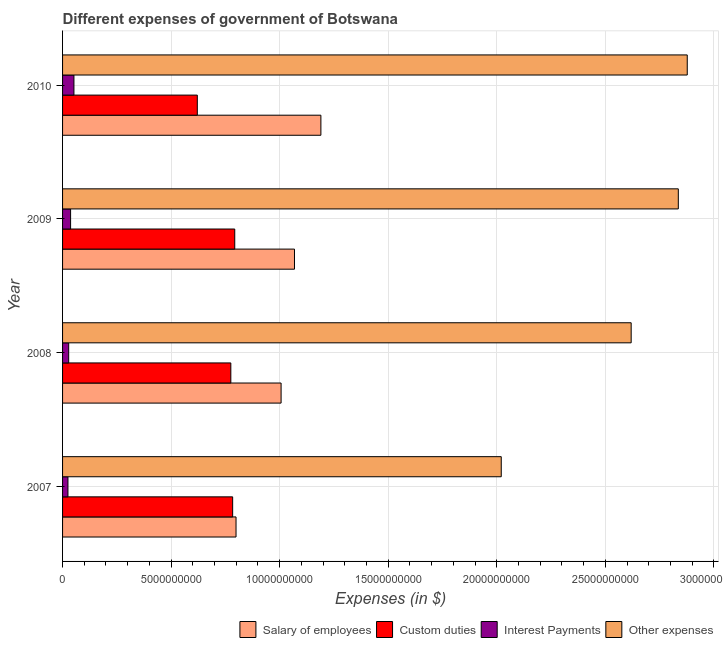Are the number of bars on each tick of the Y-axis equal?
Your answer should be compact. Yes. How many bars are there on the 3rd tick from the top?
Offer a very short reply. 4. What is the amount spent on interest payments in 2010?
Make the answer very short. 5.24e+08. Across all years, what is the maximum amount spent on salary of employees?
Keep it short and to the point. 1.19e+1. Across all years, what is the minimum amount spent on other expenses?
Give a very brief answer. 2.02e+1. In which year was the amount spent on salary of employees maximum?
Offer a terse response. 2010. What is the total amount spent on other expenses in the graph?
Make the answer very short. 1.04e+11. What is the difference between the amount spent on other expenses in 2008 and that in 2010?
Ensure brevity in your answer.  -2.58e+09. What is the difference between the amount spent on interest payments in 2009 and the amount spent on custom duties in 2007?
Offer a terse response. -7.46e+09. What is the average amount spent on interest payments per year?
Your answer should be very brief. 3.56e+08. In the year 2010, what is the difference between the amount spent on salary of employees and amount spent on custom duties?
Ensure brevity in your answer.  5.69e+09. In how many years, is the amount spent on salary of employees greater than 3000000000 $?
Ensure brevity in your answer.  4. What is the ratio of the amount spent on salary of employees in 2009 to that in 2010?
Ensure brevity in your answer.  0.9. What is the difference between the highest and the second highest amount spent on custom duties?
Make the answer very short. 9.62e+07. What is the difference between the highest and the lowest amount spent on custom duties?
Offer a terse response. 1.72e+09. In how many years, is the amount spent on salary of employees greater than the average amount spent on salary of employees taken over all years?
Provide a short and direct response. 2. Is the sum of the amount spent on salary of employees in 2008 and 2010 greater than the maximum amount spent on custom duties across all years?
Offer a terse response. Yes. Is it the case that in every year, the sum of the amount spent on interest payments and amount spent on custom duties is greater than the sum of amount spent on salary of employees and amount spent on other expenses?
Offer a terse response. Yes. What does the 3rd bar from the top in 2009 represents?
Offer a terse response. Custom duties. What does the 2nd bar from the bottom in 2009 represents?
Your answer should be compact. Custom duties. How many bars are there?
Give a very brief answer. 16. How many years are there in the graph?
Your answer should be compact. 4. Are the values on the major ticks of X-axis written in scientific E-notation?
Your response must be concise. No. Where does the legend appear in the graph?
Your response must be concise. Bottom right. How are the legend labels stacked?
Your response must be concise. Horizontal. What is the title of the graph?
Make the answer very short. Different expenses of government of Botswana. What is the label or title of the X-axis?
Your answer should be compact. Expenses (in $). What is the Expenses (in $) in Salary of employees in 2007?
Your answer should be compact. 7.99e+09. What is the Expenses (in $) in Custom duties in 2007?
Give a very brief answer. 7.83e+09. What is the Expenses (in $) of Interest Payments in 2007?
Provide a succinct answer. 2.48e+08. What is the Expenses (in $) in Other expenses in 2007?
Give a very brief answer. 2.02e+1. What is the Expenses (in $) in Salary of employees in 2008?
Your response must be concise. 1.01e+1. What is the Expenses (in $) in Custom duties in 2008?
Offer a very short reply. 7.75e+09. What is the Expenses (in $) in Interest Payments in 2008?
Your response must be concise. 2.82e+08. What is the Expenses (in $) in Other expenses in 2008?
Keep it short and to the point. 2.62e+1. What is the Expenses (in $) of Salary of employees in 2009?
Offer a very short reply. 1.07e+1. What is the Expenses (in $) in Custom duties in 2009?
Your answer should be very brief. 7.93e+09. What is the Expenses (in $) in Interest Payments in 2009?
Ensure brevity in your answer.  3.70e+08. What is the Expenses (in $) in Other expenses in 2009?
Make the answer very short. 2.84e+1. What is the Expenses (in $) of Salary of employees in 2010?
Offer a very short reply. 1.19e+1. What is the Expenses (in $) of Custom duties in 2010?
Make the answer very short. 6.21e+09. What is the Expenses (in $) in Interest Payments in 2010?
Provide a succinct answer. 5.24e+08. What is the Expenses (in $) of Other expenses in 2010?
Give a very brief answer. 2.88e+1. Across all years, what is the maximum Expenses (in $) of Salary of employees?
Provide a short and direct response. 1.19e+1. Across all years, what is the maximum Expenses (in $) of Custom duties?
Your answer should be very brief. 7.93e+09. Across all years, what is the maximum Expenses (in $) in Interest Payments?
Your answer should be compact. 5.24e+08. Across all years, what is the maximum Expenses (in $) of Other expenses?
Provide a short and direct response. 2.88e+1. Across all years, what is the minimum Expenses (in $) of Salary of employees?
Make the answer very short. 7.99e+09. Across all years, what is the minimum Expenses (in $) of Custom duties?
Your response must be concise. 6.21e+09. Across all years, what is the minimum Expenses (in $) in Interest Payments?
Make the answer very short. 2.48e+08. Across all years, what is the minimum Expenses (in $) in Other expenses?
Provide a short and direct response. 2.02e+1. What is the total Expenses (in $) of Salary of employees in the graph?
Offer a very short reply. 4.06e+1. What is the total Expenses (in $) in Custom duties in the graph?
Make the answer very short. 2.97e+1. What is the total Expenses (in $) of Interest Payments in the graph?
Offer a terse response. 1.42e+09. What is the total Expenses (in $) of Other expenses in the graph?
Your answer should be very brief. 1.04e+11. What is the difference between the Expenses (in $) in Salary of employees in 2007 and that in 2008?
Your answer should be very brief. -2.08e+09. What is the difference between the Expenses (in $) in Custom duties in 2007 and that in 2008?
Offer a very short reply. 8.47e+07. What is the difference between the Expenses (in $) in Interest Payments in 2007 and that in 2008?
Offer a very short reply. -3.36e+07. What is the difference between the Expenses (in $) in Other expenses in 2007 and that in 2008?
Provide a short and direct response. -5.98e+09. What is the difference between the Expenses (in $) in Salary of employees in 2007 and that in 2009?
Give a very brief answer. -2.69e+09. What is the difference between the Expenses (in $) in Custom duties in 2007 and that in 2009?
Provide a short and direct response. -9.62e+07. What is the difference between the Expenses (in $) of Interest Payments in 2007 and that in 2009?
Give a very brief answer. -1.21e+08. What is the difference between the Expenses (in $) of Other expenses in 2007 and that in 2009?
Your answer should be very brief. -8.16e+09. What is the difference between the Expenses (in $) in Salary of employees in 2007 and that in 2010?
Ensure brevity in your answer.  -3.91e+09. What is the difference between the Expenses (in $) of Custom duties in 2007 and that in 2010?
Give a very brief answer. 1.63e+09. What is the difference between the Expenses (in $) in Interest Payments in 2007 and that in 2010?
Keep it short and to the point. -2.75e+08. What is the difference between the Expenses (in $) in Other expenses in 2007 and that in 2010?
Offer a very short reply. -8.57e+09. What is the difference between the Expenses (in $) in Salary of employees in 2008 and that in 2009?
Provide a short and direct response. -6.17e+08. What is the difference between the Expenses (in $) in Custom duties in 2008 and that in 2009?
Offer a terse response. -1.81e+08. What is the difference between the Expenses (in $) in Interest Payments in 2008 and that in 2009?
Provide a short and direct response. -8.77e+07. What is the difference between the Expenses (in $) in Other expenses in 2008 and that in 2009?
Your answer should be compact. -2.17e+09. What is the difference between the Expenses (in $) in Salary of employees in 2008 and that in 2010?
Offer a very short reply. -1.83e+09. What is the difference between the Expenses (in $) in Custom duties in 2008 and that in 2010?
Make the answer very short. 1.54e+09. What is the difference between the Expenses (in $) of Interest Payments in 2008 and that in 2010?
Your answer should be very brief. -2.41e+08. What is the difference between the Expenses (in $) of Other expenses in 2008 and that in 2010?
Your response must be concise. -2.58e+09. What is the difference between the Expenses (in $) in Salary of employees in 2009 and that in 2010?
Your answer should be very brief. -1.22e+09. What is the difference between the Expenses (in $) of Custom duties in 2009 and that in 2010?
Make the answer very short. 1.72e+09. What is the difference between the Expenses (in $) in Interest Payments in 2009 and that in 2010?
Offer a terse response. -1.54e+08. What is the difference between the Expenses (in $) in Other expenses in 2009 and that in 2010?
Offer a terse response. -4.12e+08. What is the difference between the Expenses (in $) of Salary of employees in 2007 and the Expenses (in $) of Custom duties in 2008?
Ensure brevity in your answer.  2.40e+08. What is the difference between the Expenses (in $) of Salary of employees in 2007 and the Expenses (in $) of Interest Payments in 2008?
Your response must be concise. 7.71e+09. What is the difference between the Expenses (in $) of Salary of employees in 2007 and the Expenses (in $) of Other expenses in 2008?
Your answer should be compact. -1.82e+1. What is the difference between the Expenses (in $) of Custom duties in 2007 and the Expenses (in $) of Interest Payments in 2008?
Offer a very short reply. 7.55e+09. What is the difference between the Expenses (in $) of Custom duties in 2007 and the Expenses (in $) of Other expenses in 2008?
Make the answer very short. -1.84e+1. What is the difference between the Expenses (in $) of Interest Payments in 2007 and the Expenses (in $) of Other expenses in 2008?
Your response must be concise. -2.59e+1. What is the difference between the Expenses (in $) of Salary of employees in 2007 and the Expenses (in $) of Custom duties in 2009?
Keep it short and to the point. 5.93e+07. What is the difference between the Expenses (in $) in Salary of employees in 2007 and the Expenses (in $) in Interest Payments in 2009?
Keep it short and to the point. 7.62e+09. What is the difference between the Expenses (in $) of Salary of employees in 2007 and the Expenses (in $) of Other expenses in 2009?
Make the answer very short. -2.04e+1. What is the difference between the Expenses (in $) in Custom duties in 2007 and the Expenses (in $) in Interest Payments in 2009?
Keep it short and to the point. 7.46e+09. What is the difference between the Expenses (in $) of Custom duties in 2007 and the Expenses (in $) of Other expenses in 2009?
Provide a succinct answer. -2.05e+1. What is the difference between the Expenses (in $) of Interest Payments in 2007 and the Expenses (in $) of Other expenses in 2009?
Offer a very short reply. -2.81e+1. What is the difference between the Expenses (in $) of Salary of employees in 2007 and the Expenses (in $) of Custom duties in 2010?
Your answer should be very brief. 1.78e+09. What is the difference between the Expenses (in $) of Salary of employees in 2007 and the Expenses (in $) of Interest Payments in 2010?
Make the answer very short. 7.47e+09. What is the difference between the Expenses (in $) of Salary of employees in 2007 and the Expenses (in $) of Other expenses in 2010?
Your response must be concise. -2.08e+1. What is the difference between the Expenses (in $) in Custom duties in 2007 and the Expenses (in $) in Interest Payments in 2010?
Your answer should be very brief. 7.31e+09. What is the difference between the Expenses (in $) of Custom duties in 2007 and the Expenses (in $) of Other expenses in 2010?
Offer a very short reply. -2.09e+1. What is the difference between the Expenses (in $) of Interest Payments in 2007 and the Expenses (in $) of Other expenses in 2010?
Your answer should be very brief. -2.85e+1. What is the difference between the Expenses (in $) of Salary of employees in 2008 and the Expenses (in $) of Custom duties in 2009?
Ensure brevity in your answer.  2.13e+09. What is the difference between the Expenses (in $) in Salary of employees in 2008 and the Expenses (in $) in Interest Payments in 2009?
Offer a terse response. 9.70e+09. What is the difference between the Expenses (in $) in Salary of employees in 2008 and the Expenses (in $) in Other expenses in 2009?
Provide a short and direct response. -1.83e+1. What is the difference between the Expenses (in $) of Custom duties in 2008 and the Expenses (in $) of Interest Payments in 2009?
Make the answer very short. 7.38e+09. What is the difference between the Expenses (in $) in Custom duties in 2008 and the Expenses (in $) in Other expenses in 2009?
Make the answer very short. -2.06e+1. What is the difference between the Expenses (in $) in Interest Payments in 2008 and the Expenses (in $) in Other expenses in 2009?
Offer a very short reply. -2.81e+1. What is the difference between the Expenses (in $) in Salary of employees in 2008 and the Expenses (in $) in Custom duties in 2010?
Provide a succinct answer. 3.86e+09. What is the difference between the Expenses (in $) in Salary of employees in 2008 and the Expenses (in $) in Interest Payments in 2010?
Your answer should be compact. 9.54e+09. What is the difference between the Expenses (in $) of Salary of employees in 2008 and the Expenses (in $) of Other expenses in 2010?
Give a very brief answer. -1.87e+1. What is the difference between the Expenses (in $) in Custom duties in 2008 and the Expenses (in $) in Interest Payments in 2010?
Provide a short and direct response. 7.23e+09. What is the difference between the Expenses (in $) in Custom duties in 2008 and the Expenses (in $) in Other expenses in 2010?
Ensure brevity in your answer.  -2.10e+1. What is the difference between the Expenses (in $) of Interest Payments in 2008 and the Expenses (in $) of Other expenses in 2010?
Give a very brief answer. -2.85e+1. What is the difference between the Expenses (in $) in Salary of employees in 2009 and the Expenses (in $) in Custom duties in 2010?
Keep it short and to the point. 4.48e+09. What is the difference between the Expenses (in $) in Salary of employees in 2009 and the Expenses (in $) in Interest Payments in 2010?
Your answer should be compact. 1.02e+1. What is the difference between the Expenses (in $) in Salary of employees in 2009 and the Expenses (in $) in Other expenses in 2010?
Offer a terse response. -1.81e+1. What is the difference between the Expenses (in $) in Custom duties in 2009 and the Expenses (in $) in Interest Payments in 2010?
Your answer should be very brief. 7.41e+09. What is the difference between the Expenses (in $) of Custom duties in 2009 and the Expenses (in $) of Other expenses in 2010?
Your response must be concise. -2.08e+1. What is the difference between the Expenses (in $) in Interest Payments in 2009 and the Expenses (in $) in Other expenses in 2010?
Offer a very short reply. -2.84e+1. What is the average Expenses (in $) of Salary of employees per year?
Your response must be concise. 1.02e+1. What is the average Expenses (in $) in Custom duties per year?
Offer a terse response. 7.43e+09. What is the average Expenses (in $) of Interest Payments per year?
Provide a short and direct response. 3.56e+08. What is the average Expenses (in $) in Other expenses per year?
Your response must be concise. 2.59e+1. In the year 2007, what is the difference between the Expenses (in $) of Salary of employees and Expenses (in $) of Custom duties?
Your answer should be very brief. 1.55e+08. In the year 2007, what is the difference between the Expenses (in $) of Salary of employees and Expenses (in $) of Interest Payments?
Provide a succinct answer. 7.74e+09. In the year 2007, what is the difference between the Expenses (in $) in Salary of employees and Expenses (in $) in Other expenses?
Your answer should be very brief. -1.22e+1. In the year 2007, what is the difference between the Expenses (in $) of Custom duties and Expenses (in $) of Interest Payments?
Give a very brief answer. 7.59e+09. In the year 2007, what is the difference between the Expenses (in $) of Custom duties and Expenses (in $) of Other expenses?
Your response must be concise. -1.24e+1. In the year 2007, what is the difference between the Expenses (in $) in Interest Payments and Expenses (in $) in Other expenses?
Make the answer very short. -2.00e+1. In the year 2008, what is the difference between the Expenses (in $) of Salary of employees and Expenses (in $) of Custom duties?
Provide a succinct answer. 2.32e+09. In the year 2008, what is the difference between the Expenses (in $) in Salary of employees and Expenses (in $) in Interest Payments?
Provide a short and direct response. 9.78e+09. In the year 2008, what is the difference between the Expenses (in $) of Salary of employees and Expenses (in $) of Other expenses?
Provide a short and direct response. -1.61e+1. In the year 2008, what is the difference between the Expenses (in $) in Custom duties and Expenses (in $) in Interest Payments?
Offer a very short reply. 7.47e+09. In the year 2008, what is the difference between the Expenses (in $) of Custom duties and Expenses (in $) of Other expenses?
Provide a succinct answer. -1.84e+1. In the year 2008, what is the difference between the Expenses (in $) of Interest Payments and Expenses (in $) of Other expenses?
Your response must be concise. -2.59e+1. In the year 2009, what is the difference between the Expenses (in $) in Salary of employees and Expenses (in $) in Custom duties?
Your answer should be compact. 2.75e+09. In the year 2009, what is the difference between the Expenses (in $) in Salary of employees and Expenses (in $) in Interest Payments?
Provide a short and direct response. 1.03e+1. In the year 2009, what is the difference between the Expenses (in $) in Salary of employees and Expenses (in $) in Other expenses?
Provide a short and direct response. -1.77e+1. In the year 2009, what is the difference between the Expenses (in $) in Custom duties and Expenses (in $) in Interest Payments?
Provide a short and direct response. 7.56e+09. In the year 2009, what is the difference between the Expenses (in $) of Custom duties and Expenses (in $) of Other expenses?
Ensure brevity in your answer.  -2.04e+1. In the year 2009, what is the difference between the Expenses (in $) in Interest Payments and Expenses (in $) in Other expenses?
Your answer should be compact. -2.80e+1. In the year 2010, what is the difference between the Expenses (in $) in Salary of employees and Expenses (in $) in Custom duties?
Your answer should be very brief. 5.69e+09. In the year 2010, what is the difference between the Expenses (in $) of Salary of employees and Expenses (in $) of Interest Payments?
Provide a short and direct response. 1.14e+1. In the year 2010, what is the difference between the Expenses (in $) of Salary of employees and Expenses (in $) of Other expenses?
Keep it short and to the point. -1.69e+1. In the year 2010, what is the difference between the Expenses (in $) in Custom duties and Expenses (in $) in Interest Payments?
Keep it short and to the point. 5.68e+09. In the year 2010, what is the difference between the Expenses (in $) in Custom duties and Expenses (in $) in Other expenses?
Provide a succinct answer. -2.26e+1. In the year 2010, what is the difference between the Expenses (in $) in Interest Payments and Expenses (in $) in Other expenses?
Give a very brief answer. -2.83e+1. What is the ratio of the Expenses (in $) in Salary of employees in 2007 to that in 2008?
Provide a succinct answer. 0.79. What is the ratio of the Expenses (in $) of Custom duties in 2007 to that in 2008?
Make the answer very short. 1.01. What is the ratio of the Expenses (in $) in Interest Payments in 2007 to that in 2008?
Give a very brief answer. 0.88. What is the ratio of the Expenses (in $) in Other expenses in 2007 to that in 2008?
Your answer should be compact. 0.77. What is the ratio of the Expenses (in $) of Salary of employees in 2007 to that in 2009?
Offer a very short reply. 0.75. What is the ratio of the Expenses (in $) in Custom duties in 2007 to that in 2009?
Your answer should be very brief. 0.99. What is the ratio of the Expenses (in $) of Interest Payments in 2007 to that in 2009?
Your response must be concise. 0.67. What is the ratio of the Expenses (in $) in Other expenses in 2007 to that in 2009?
Ensure brevity in your answer.  0.71. What is the ratio of the Expenses (in $) of Salary of employees in 2007 to that in 2010?
Provide a short and direct response. 0.67. What is the ratio of the Expenses (in $) in Custom duties in 2007 to that in 2010?
Provide a short and direct response. 1.26. What is the ratio of the Expenses (in $) of Interest Payments in 2007 to that in 2010?
Your answer should be compact. 0.47. What is the ratio of the Expenses (in $) of Other expenses in 2007 to that in 2010?
Give a very brief answer. 0.7. What is the ratio of the Expenses (in $) of Salary of employees in 2008 to that in 2009?
Provide a succinct answer. 0.94. What is the ratio of the Expenses (in $) in Custom duties in 2008 to that in 2009?
Your answer should be very brief. 0.98. What is the ratio of the Expenses (in $) in Interest Payments in 2008 to that in 2009?
Your response must be concise. 0.76. What is the ratio of the Expenses (in $) of Other expenses in 2008 to that in 2009?
Offer a terse response. 0.92. What is the ratio of the Expenses (in $) of Salary of employees in 2008 to that in 2010?
Your answer should be compact. 0.85. What is the ratio of the Expenses (in $) of Custom duties in 2008 to that in 2010?
Make the answer very short. 1.25. What is the ratio of the Expenses (in $) in Interest Payments in 2008 to that in 2010?
Give a very brief answer. 0.54. What is the ratio of the Expenses (in $) of Other expenses in 2008 to that in 2010?
Offer a terse response. 0.91. What is the ratio of the Expenses (in $) of Salary of employees in 2009 to that in 2010?
Offer a terse response. 0.9. What is the ratio of the Expenses (in $) of Custom duties in 2009 to that in 2010?
Provide a succinct answer. 1.28. What is the ratio of the Expenses (in $) of Interest Payments in 2009 to that in 2010?
Keep it short and to the point. 0.71. What is the ratio of the Expenses (in $) in Other expenses in 2009 to that in 2010?
Offer a very short reply. 0.99. What is the difference between the highest and the second highest Expenses (in $) in Salary of employees?
Provide a short and direct response. 1.22e+09. What is the difference between the highest and the second highest Expenses (in $) in Custom duties?
Make the answer very short. 9.62e+07. What is the difference between the highest and the second highest Expenses (in $) of Interest Payments?
Offer a terse response. 1.54e+08. What is the difference between the highest and the second highest Expenses (in $) in Other expenses?
Offer a very short reply. 4.12e+08. What is the difference between the highest and the lowest Expenses (in $) of Salary of employees?
Make the answer very short. 3.91e+09. What is the difference between the highest and the lowest Expenses (in $) in Custom duties?
Offer a terse response. 1.72e+09. What is the difference between the highest and the lowest Expenses (in $) of Interest Payments?
Give a very brief answer. 2.75e+08. What is the difference between the highest and the lowest Expenses (in $) in Other expenses?
Give a very brief answer. 8.57e+09. 